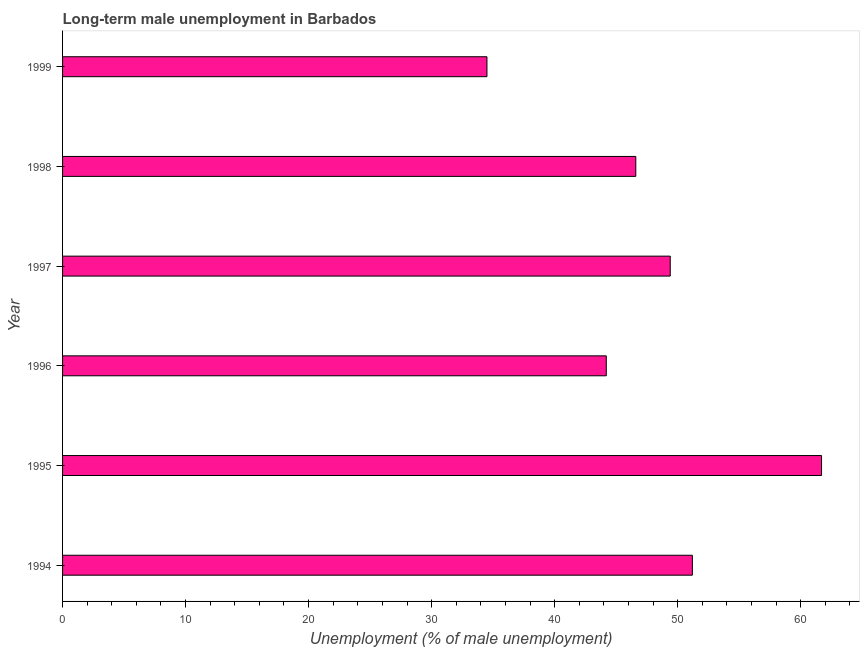What is the title of the graph?
Make the answer very short. Long-term male unemployment in Barbados. What is the label or title of the X-axis?
Provide a short and direct response. Unemployment (% of male unemployment). What is the label or title of the Y-axis?
Your answer should be very brief. Year. What is the long-term male unemployment in 1996?
Your answer should be compact. 44.2. Across all years, what is the maximum long-term male unemployment?
Provide a succinct answer. 61.7. Across all years, what is the minimum long-term male unemployment?
Make the answer very short. 34.5. In which year was the long-term male unemployment maximum?
Your answer should be compact. 1995. In which year was the long-term male unemployment minimum?
Your answer should be very brief. 1999. What is the sum of the long-term male unemployment?
Provide a short and direct response. 287.6. What is the difference between the long-term male unemployment in 1996 and 1999?
Make the answer very short. 9.7. What is the average long-term male unemployment per year?
Offer a terse response. 47.93. In how many years, is the long-term male unemployment greater than 2 %?
Provide a short and direct response. 6. Do a majority of the years between 1998 and 1994 (inclusive) have long-term male unemployment greater than 26 %?
Offer a terse response. Yes. What is the ratio of the long-term male unemployment in 1995 to that in 1999?
Give a very brief answer. 1.79. Is the long-term male unemployment in 1995 less than that in 1999?
Your response must be concise. No. Is the sum of the long-term male unemployment in 1995 and 1996 greater than the maximum long-term male unemployment across all years?
Your answer should be compact. Yes. What is the difference between the highest and the lowest long-term male unemployment?
Keep it short and to the point. 27.2. In how many years, is the long-term male unemployment greater than the average long-term male unemployment taken over all years?
Ensure brevity in your answer.  3. How many years are there in the graph?
Make the answer very short. 6. What is the Unemployment (% of male unemployment) of 1994?
Offer a terse response. 51.2. What is the Unemployment (% of male unemployment) in 1995?
Your answer should be very brief. 61.7. What is the Unemployment (% of male unemployment) in 1996?
Offer a very short reply. 44.2. What is the Unemployment (% of male unemployment) in 1997?
Provide a succinct answer. 49.4. What is the Unemployment (% of male unemployment) of 1998?
Make the answer very short. 46.6. What is the Unemployment (% of male unemployment) in 1999?
Offer a very short reply. 34.5. What is the difference between the Unemployment (% of male unemployment) in 1994 and 1995?
Your answer should be compact. -10.5. What is the difference between the Unemployment (% of male unemployment) in 1994 and 1996?
Offer a very short reply. 7. What is the difference between the Unemployment (% of male unemployment) in 1994 and 1997?
Provide a short and direct response. 1.8. What is the difference between the Unemployment (% of male unemployment) in 1994 and 1998?
Make the answer very short. 4.6. What is the difference between the Unemployment (% of male unemployment) in 1994 and 1999?
Offer a very short reply. 16.7. What is the difference between the Unemployment (% of male unemployment) in 1995 and 1996?
Offer a very short reply. 17.5. What is the difference between the Unemployment (% of male unemployment) in 1995 and 1997?
Make the answer very short. 12.3. What is the difference between the Unemployment (% of male unemployment) in 1995 and 1998?
Your answer should be very brief. 15.1. What is the difference between the Unemployment (% of male unemployment) in 1995 and 1999?
Your answer should be very brief. 27.2. What is the difference between the Unemployment (% of male unemployment) in 1996 and 1998?
Give a very brief answer. -2.4. What is the difference between the Unemployment (% of male unemployment) in 1997 and 1999?
Your answer should be compact. 14.9. What is the difference between the Unemployment (% of male unemployment) in 1998 and 1999?
Provide a short and direct response. 12.1. What is the ratio of the Unemployment (% of male unemployment) in 1994 to that in 1995?
Provide a succinct answer. 0.83. What is the ratio of the Unemployment (% of male unemployment) in 1994 to that in 1996?
Provide a short and direct response. 1.16. What is the ratio of the Unemployment (% of male unemployment) in 1994 to that in 1997?
Your answer should be very brief. 1.04. What is the ratio of the Unemployment (% of male unemployment) in 1994 to that in 1998?
Ensure brevity in your answer.  1.1. What is the ratio of the Unemployment (% of male unemployment) in 1994 to that in 1999?
Give a very brief answer. 1.48. What is the ratio of the Unemployment (% of male unemployment) in 1995 to that in 1996?
Your answer should be compact. 1.4. What is the ratio of the Unemployment (% of male unemployment) in 1995 to that in 1997?
Your response must be concise. 1.25. What is the ratio of the Unemployment (% of male unemployment) in 1995 to that in 1998?
Offer a terse response. 1.32. What is the ratio of the Unemployment (% of male unemployment) in 1995 to that in 1999?
Your answer should be very brief. 1.79. What is the ratio of the Unemployment (% of male unemployment) in 1996 to that in 1997?
Keep it short and to the point. 0.9. What is the ratio of the Unemployment (% of male unemployment) in 1996 to that in 1998?
Give a very brief answer. 0.95. What is the ratio of the Unemployment (% of male unemployment) in 1996 to that in 1999?
Provide a short and direct response. 1.28. What is the ratio of the Unemployment (% of male unemployment) in 1997 to that in 1998?
Your answer should be compact. 1.06. What is the ratio of the Unemployment (% of male unemployment) in 1997 to that in 1999?
Ensure brevity in your answer.  1.43. What is the ratio of the Unemployment (% of male unemployment) in 1998 to that in 1999?
Provide a short and direct response. 1.35. 